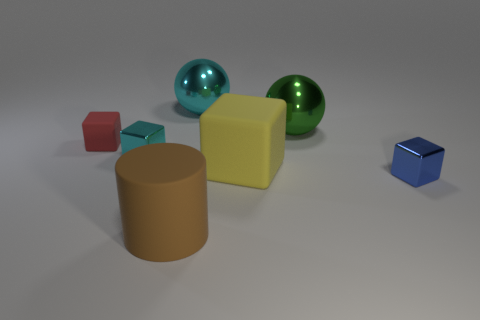Subtract all small blue blocks. How many blocks are left? 3 Add 2 yellow balls. How many objects exist? 9 Subtract all cyan blocks. How many blocks are left? 3 Subtract 3 cubes. How many cubes are left? 1 Subtract all balls. How many objects are left? 5 Subtract all blue objects. Subtract all large green things. How many objects are left? 5 Add 2 large shiny things. How many large shiny things are left? 4 Add 4 big rubber cubes. How many big rubber cubes exist? 5 Subtract 1 green balls. How many objects are left? 6 Subtract all blue cylinders. Subtract all blue cubes. How many cylinders are left? 1 